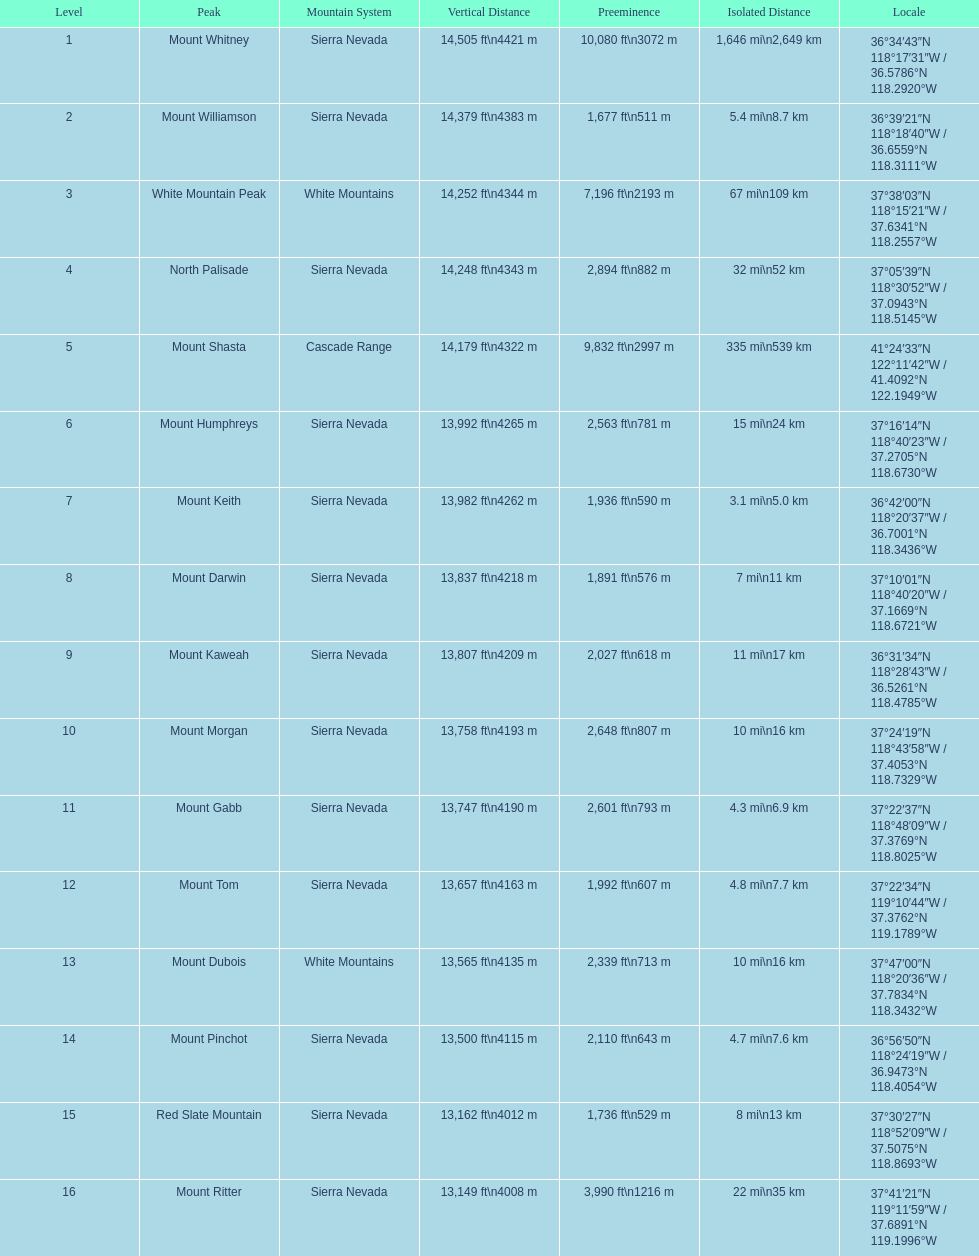Which mountain peak has the most isolation? Mount Whitney. Give me the full table as a dictionary. {'header': ['Level', 'Peak', 'Mountain System', 'Vertical Distance', 'Preeminence', 'Isolated Distance', 'Locale'], 'rows': [['1', 'Mount Whitney', 'Sierra Nevada', '14,505\xa0ft\\n4421\xa0m', '10,080\xa0ft\\n3072\xa0m', '1,646\xa0mi\\n2,649\xa0km', '36°34′43″N 118°17′31″W\ufeff / \ufeff36.5786°N 118.2920°W'], ['2', 'Mount Williamson', 'Sierra Nevada', '14,379\xa0ft\\n4383\xa0m', '1,677\xa0ft\\n511\xa0m', '5.4\xa0mi\\n8.7\xa0km', '36°39′21″N 118°18′40″W\ufeff / \ufeff36.6559°N 118.3111°W'], ['3', 'White Mountain Peak', 'White Mountains', '14,252\xa0ft\\n4344\xa0m', '7,196\xa0ft\\n2193\xa0m', '67\xa0mi\\n109\xa0km', '37°38′03″N 118°15′21″W\ufeff / \ufeff37.6341°N 118.2557°W'], ['4', 'North Palisade', 'Sierra Nevada', '14,248\xa0ft\\n4343\xa0m', '2,894\xa0ft\\n882\xa0m', '32\xa0mi\\n52\xa0km', '37°05′39″N 118°30′52″W\ufeff / \ufeff37.0943°N 118.5145°W'], ['5', 'Mount Shasta', 'Cascade Range', '14,179\xa0ft\\n4322\xa0m', '9,832\xa0ft\\n2997\xa0m', '335\xa0mi\\n539\xa0km', '41°24′33″N 122°11′42″W\ufeff / \ufeff41.4092°N 122.1949°W'], ['6', 'Mount Humphreys', 'Sierra Nevada', '13,992\xa0ft\\n4265\xa0m', '2,563\xa0ft\\n781\xa0m', '15\xa0mi\\n24\xa0km', '37°16′14″N 118°40′23″W\ufeff / \ufeff37.2705°N 118.6730°W'], ['7', 'Mount Keith', 'Sierra Nevada', '13,982\xa0ft\\n4262\xa0m', '1,936\xa0ft\\n590\xa0m', '3.1\xa0mi\\n5.0\xa0km', '36°42′00″N 118°20′37″W\ufeff / \ufeff36.7001°N 118.3436°W'], ['8', 'Mount Darwin', 'Sierra Nevada', '13,837\xa0ft\\n4218\xa0m', '1,891\xa0ft\\n576\xa0m', '7\xa0mi\\n11\xa0km', '37°10′01″N 118°40′20″W\ufeff / \ufeff37.1669°N 118.6721°W'], ['9', 'Mount Kaweah', 'Sierra Nevada', '13,807\xa0ft\\n4209\xa0m', '2,027\xa0ft\\n618\xa0m', '11\xa0mi\\n17\xa0km', '36°31′34″N 118°28′43″W\ufeff / \ufeff36.5261°N 118.4785°W'], ['10', 'Mount Morgan', 'Sierra Nevada', '13,758\xa0ft\\n4193\xa0m', '2,648\xa0ft\\n807\xa0m', '10\xa0mi\\n16\xa0km', '37°24′19″N 118°43′58″W\ufeff / \ufeff37.4053°N 118.7329°W'], ['11', 'Mount Gabb', 'Sierra Nevada', '13,747\xa0ft\\n4190\xa0m', '2,601\xa0ft\\n793\xa0m', '4.3\xa0mi\\n6.9\xa0km', '37°22′37″N 118°48′09″W\ufeff / \ufeff37.3769°N 118.8025°W'], ['12', 'Mount Tom', 'Sierra Nevada', '13,657\xa0ft\\n4163\xa0m', '1,992\xa0ft\\n607\xa0m', '4.8\xa0mi\\n7.7\xa0km', '37°22′34″N 119°10′44″W\ufeff / \ufeff37.3762°N 119.1789°W'], ['13', 'Mount Dubois', 'White Mountains', '13,565\xa0ft\\n4135\xa0m', '2,339\xa0ft\\n713\xa0m', '10\xa0mi\\n16\xa0km', '37°47′00″N 118°20′36″W\ufeff / \ufeff37.7834°N 118.3432°W'], ['14', 'Mount Pinchot', 'Sierra Nevada', '13,500\xa0ft\\n4115\xa0m', '2,110\xa0ft\\n643\xa0m', '4.7\xa0mi\\n7.6\xa0km', '36°56′50″N 118°24′19″W\ufeff / \ufeff36.9473°N 118.4054°W'], ['15', 'Red Slate Mountain', 'Sierra Nevada', '13,162\xa0ft\\n4012\xa0m', '1,736\xa0ft\\n529\xa0m', '8\xa0mi\\n13\xa0km', '37°30′27″N 118°52′09″W\ufeff / \ufeff37.5075°N 118.8693°W'], ['16', 'Mount Ritter', 'Sierra Nevada', '13,149\xa0ft\\n4008\xa0m', '3,990\xa0ft\\n1216\xa0m', '22\xa0mi\\n35\xa0km', '37°41′21″N 119°11′59″W\ufeff / \ufeff37.6891°N 119.1996°W']]} 